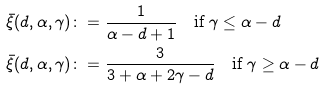Convert formula to latex. <formula><loc_0><loc_0><loc_500><loc_500>\bar { \xi } ( d , \alpha , \gamma ) & \colon = \frac { 1 } { \alpha - d + 1 } \quad \text {if $\gamma\leq \alpha-d$} \\ \bar { \xi } ( d , \alpha , \gamma ) & \colon = \frac { 3 } { 3 + \alpha + 2 \gamma - d } \quad \text {if $\gamma\geq \alpha-d$}</formula> 